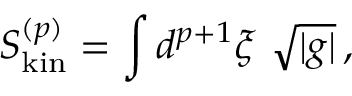<formula> <loc_0><loc_0><loc_500><loc_500>S _ { k i n } ^ { ( p ) } = \int d ^ { p + 1 } \xi \ \sqrt { | g | } \, ,</formula> 